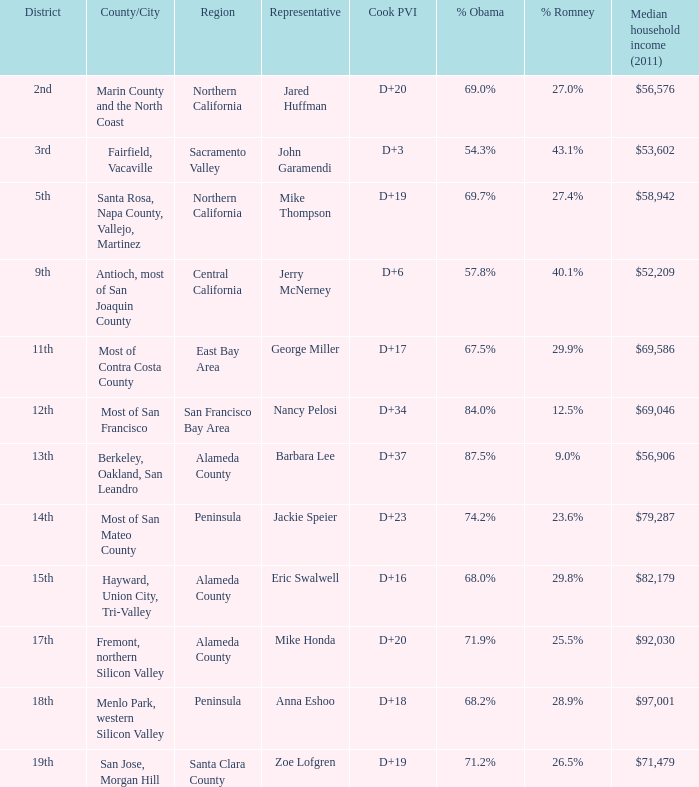How many election results in 2012 had a Cook PVI of D+16? 1.0. 